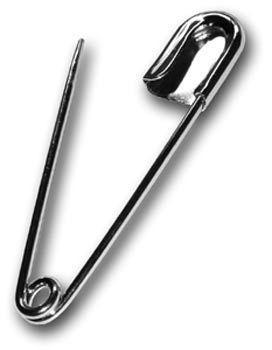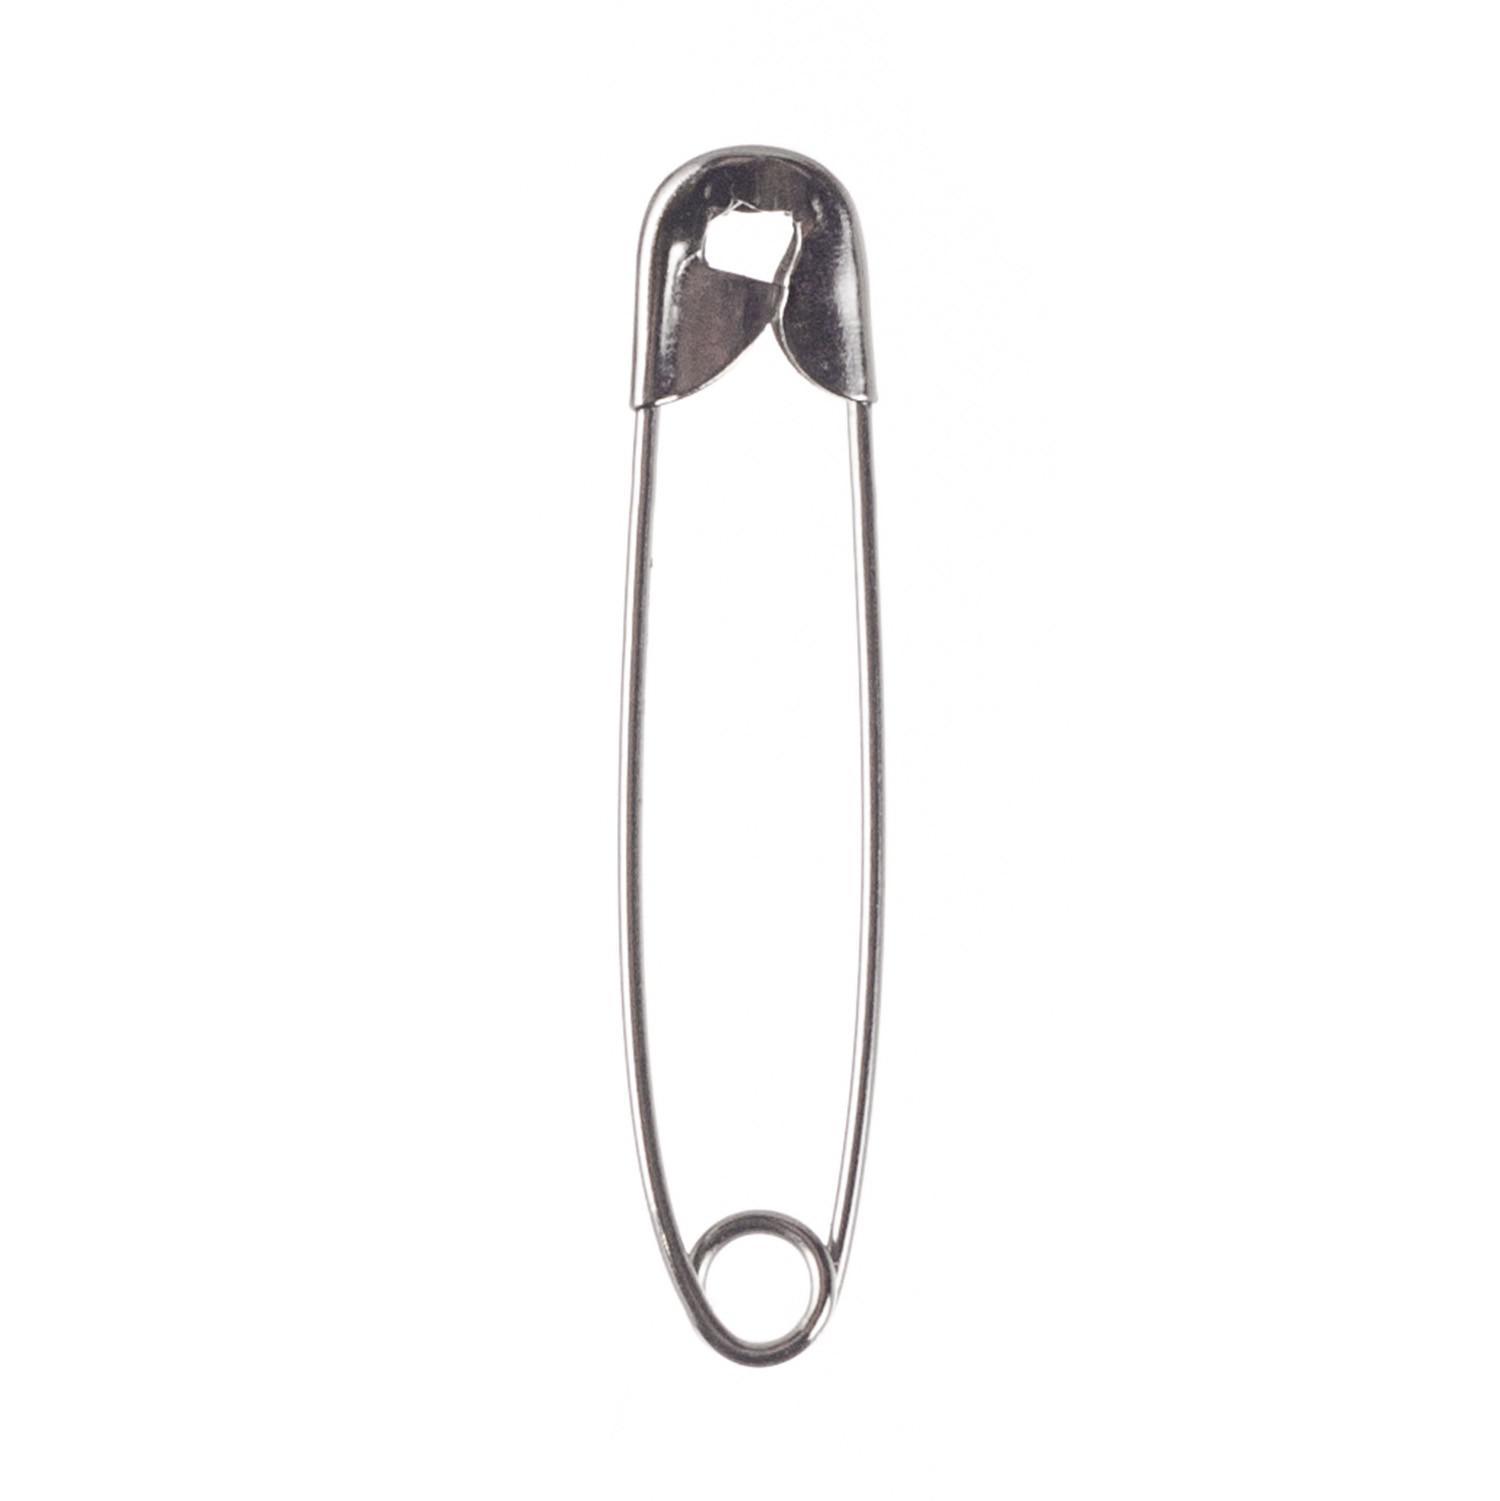The first image is the image on the left, the second image is the image on the right. Assess this claim about the two images: "An image shows one standard type closed safety pin, with a loop on one end and a metal cap clasp on the other.". Correct or not? Answer yes or no. Yes. The first image is the image on the left, the second image is the image on the right. Considering the images on both sides, is "One safety pin is in the closed position, while a second safety pin of the same color, with its shadow clearly visible, is open." valid? Answer yes or no. Yes. 